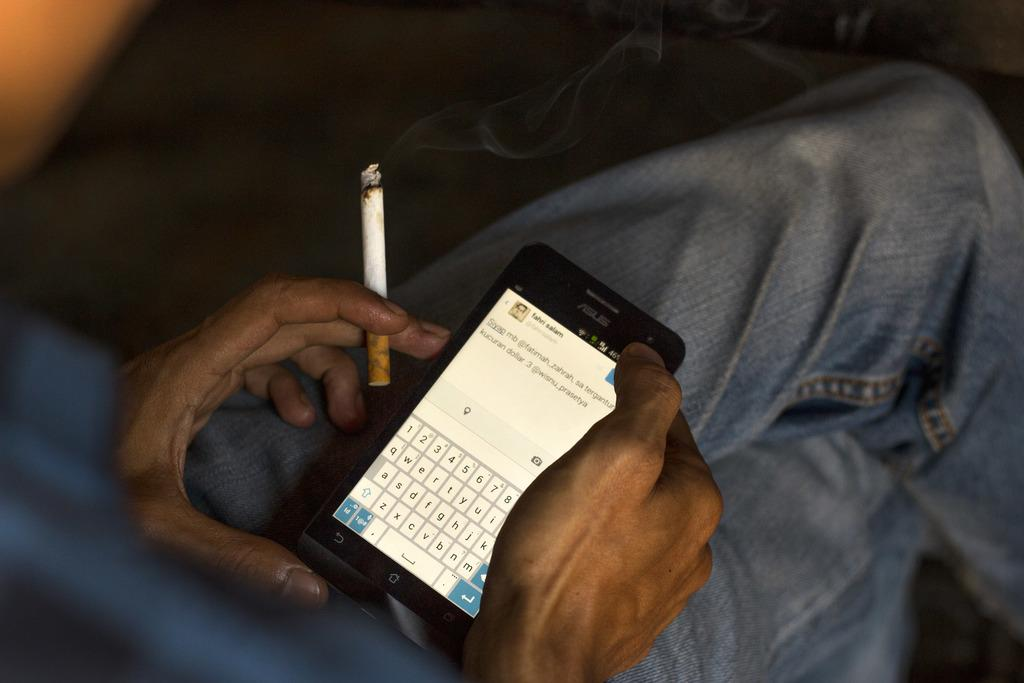What can be seen in the image? There is a person in the image. Can you describe the person's appearance? The person's face is not visible in the image. What is the person holding in the image? The person is holding a phone and a cigarette. What type of music is the person listening to on their phone in the image? There is no information about the type of music the person might be listening to on their phone in the image. 